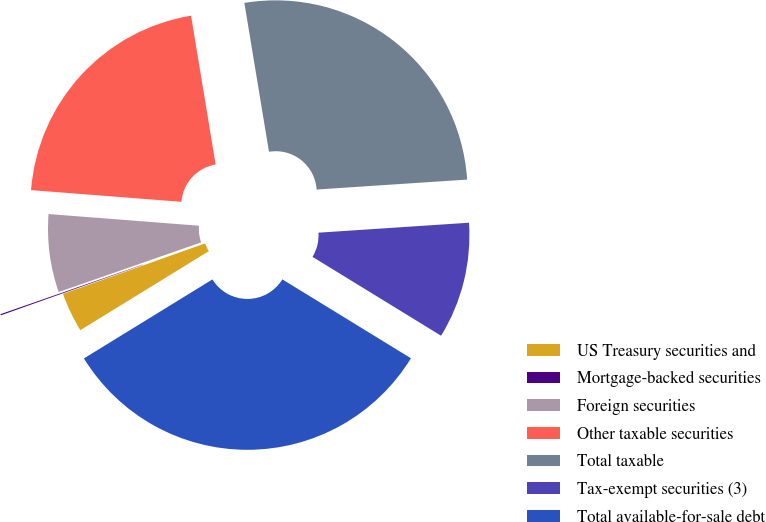<chart> <loc_0><loc_0><loc_500><loc_500><pie_chart><fcel>US Treasury securities and<fcel>Mortgage-backed securities<fcel>Foreign securities<fcel>Other taxable securities<fcel>Total taxable<fcel>Tax-exempt securities (3)<fcel>Total available-for-sale debt<nl><fcel>3.34%<fcel>0.1%<fcel>6.57%<fcel>21.16%<fcel>26.56%<fcel>9.81%<fcel>32.47%<nl></chart> 